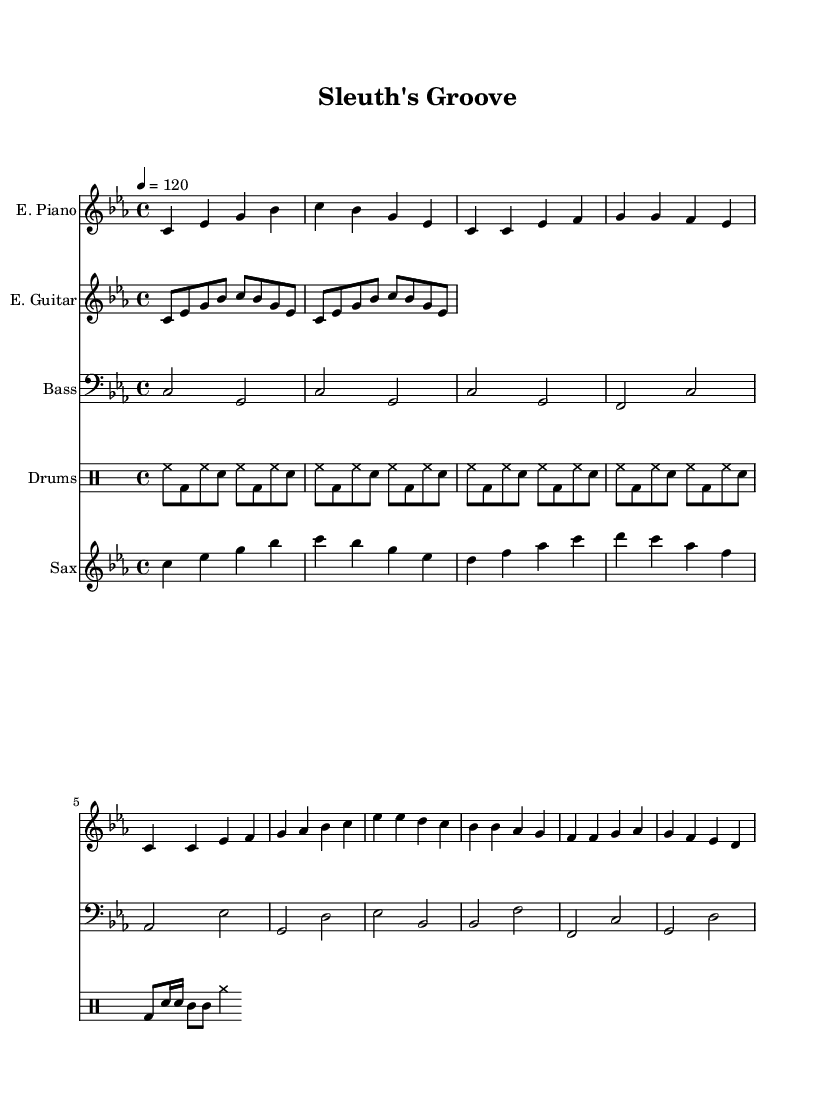What is the key signature of this music? The key signature is C minor, which contains three flats: B flat, E flat, and A flat. This is indicated at the beginning of the staff.
Answer: C minor What is the time signature of this music? The time signature is 4/4, which is shown at the beginning of the score and indicates that there are four quarter note beats in each measure.
Answer: 4/4 What is the tempo marking for this piece? The tempo marking is 120 beats per minute, noted in the tempo directive at the beginning of the score.
Answer: 120 How many measures are in the intro for the electric piano? The intro for the electric piano consists of two measures, as indicated by the two sets of notes before moving into the verse section.
Answer: 2 What instruments are featured in this composition? The instruments featured include electric piano, electric guitar, bass guitar, drums, and saxophone, as seen in the different staffs labeled at the beginning of the score.
Answer: Electric piano, electric guitar, bass guitar, drums, saxophone Which section of the music has a saxophone solo? The saxophone solo occurs in the part labeled "saxophone," which contains notes that are distinct from other instruments, specifically marked after the chorus section.
Answer: Saxophone How is the rhythm for the drums structured in the first four measures? The drums display a rhythm of alternating hi-hat, bass drum, and snare patterns, as shown in the drum part over the first four measures with hitchat and bass drum alternating through the measures.
Answer: Alternating hi-hat and bass 